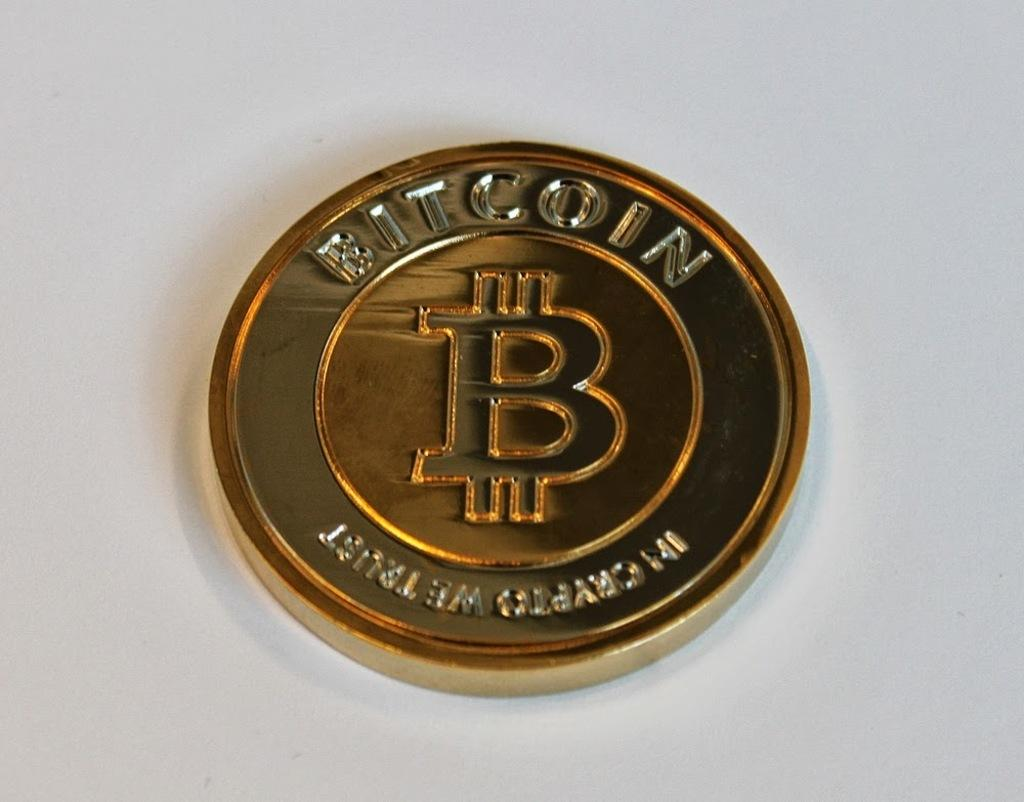<image>
Present a compact description of the photo's key features. a shiny Bit Coin on a white table on display 